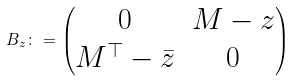<formula> <loc_0><loc_0><loc_500><loc_500>B _ { z } \colon = \begin{pmatrix} 0 & M - z \\ M ^ { \top } - \bar { z } & 0 \end{pmatrix}</formula> 